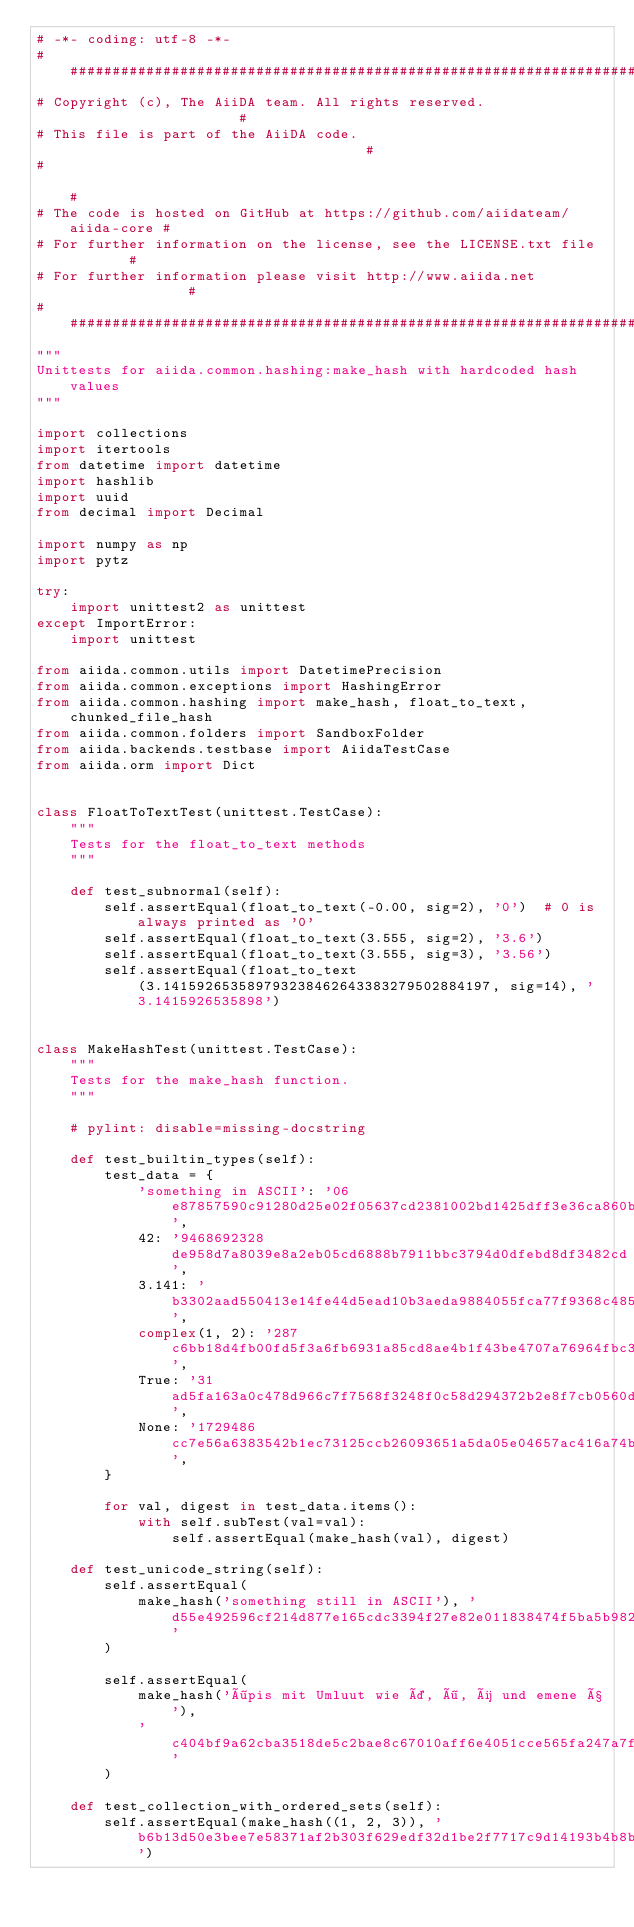<code> <loc_0><loc_0><loc_500><loc_500><_Python_># -*- coding: utf-8 -*-
###########################################################################
# Copyright (c), The AiiDA team. All rights reserved.                     #
# This file is part of the AiiDA code.                                    #
#                                                                         #
# The code is hosted on GitHub at https://github.com/aiidateam/aiida-core #
# For further information on the license, see the LICENSE.txt file        #
# For further information please visit http://www.aiida.net               #
###########################################################################
"""
Unittests for aiida.common.hashing:make_hash with hardcoded hash values
"""

import collections
import itertools
from datetime import datetime
import hashlib
import uuid
from decimal import Decimal

import numpy as np
import pytz

try:
    import unittest2 as unittest
except ImportError:
    import unittest

from aiida.common.utils import DatetimePrecision
from aiida.common.exceptions import HashingError
from aiida.common.hashing import make_hash, float_to_text, chunked_file_hash
from aiida.common.folders import SandboxFolder
from aiida.backends.testbase import AiidaTestCase
from aiida.orm import Dict


class FloatToTextTest(unittest.TestCase):
    """
    Tests for the float_to_text methods
    """

    def test_subnormal(self):
        self.assertEqual(float_to_text(-0.00, sig=2), '0')  # 0 is always printed as '0'
        self.assertEqual(float_to_text(3.555, sig=2), '3.6')
        self.assertEqual(float_to_text(3.555, sig=3), '3.56')
        self.assertEqual(float_to_text(3.141592653589793238462643383279502884197, sig=14), '3.1415926535898')


class MakeHashTest(unittest.TestCase):
    """
    Tests for the make_hash function.
    """

    # pylint: disable=missing-docstring

    def test_builtin_types(self):
        test_data = {
            'something in ASCII': '06e87857590c91280d25e02f05637cd2381002bd1425dff3e36ca860bbb26a29',
            42: '9468692328de958d7a8039e8a2eb05cd6888b7911bbc3794d0dfebd8df3482cd',
            3.141: 'b3302aad550413e14fe44d5ead10b3aeda9884055fca77f9368c48517916d4be',
            complex(1, 2): '287c6bb18d4fb00fd5f3a6fb6931a85cd8ae4b1f43be4707a76964fbc322872e',
            True: '31ad5fa163a0c478d966c7f7568f3248f0c58d294372b2e8f7cb0560d8c8b12f',
            None: '1729486cc7e56a6383542b1ec73125ccb26093651a5da05e04657ac416a74b8f',
        }

        for val, digest in test_data.items():
            with self.subTest(val=val):
                self.assertEqual(make_hash(val), digest)

    def test_unicode_string(self):
        self.assertEqual(
            make_hash('something still in ASCII'), 'd55e492596cf214d877e165cdc3394f27e82e011838474f5ba5b9824074b9e91'
        )

        self.assertEqual(
            make_hash('öpis mit Umluut wie ä, ö, ü und emene ß'),
            'c404bf9a62cba3518de5c2bae8c67010aff6e4051cce565fa247a7f1d71f1fc7'
        )

    def test_collection_with_ordered_sets(self):
        self.assertEqual(make_hash((1, 2, 3)), 'b6b13d50e3bee7e58371af2b303f629edf32d1be2f7717c9d14193b4b8b23e04')</code> 